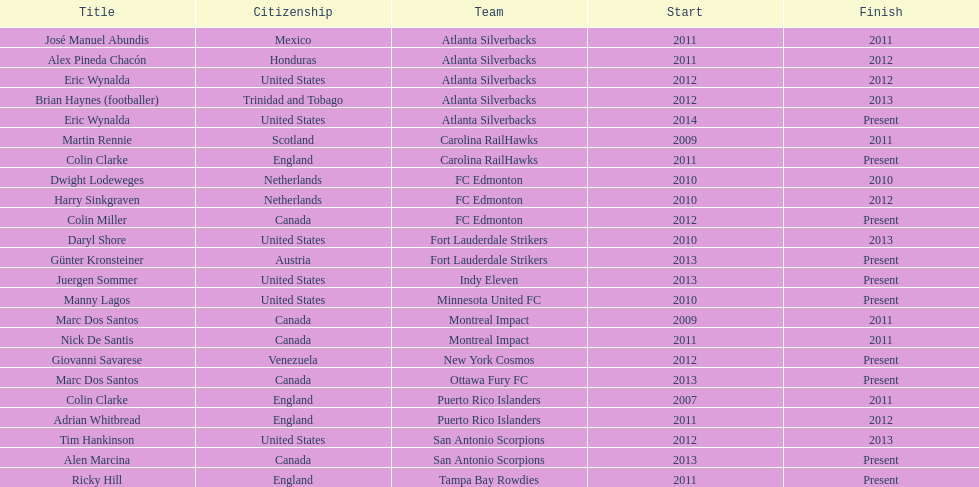What name is listed at the top? José Manuel Abundis. Would you be able to parse every entry in this table? {'header': ['Title', 'Citizenship', 'Team', 'Start', 'Finish'], 'rows': [['José Manuel Abundis', 'Mexico', 'Atlanta Silverbacks', '2011', '2011'], ['Alex Pineda Chacón', 'Honduras', 'Atlanta Silverbacks', '2011', '2012'], ['Eric Wynalda', 'United States', 'Atlanta Silverbacks', '2012', '2012'], ['Brian Haynes (footballer)', 'Trinidad and Tobago', 'Atlanta Silverbacks', '2012', '2013'], ['Eric Wynalda', 'United States', 'Atlanta Silverbacks', '2014', 'Present'], ['Martin Rennie', 'Scotland', 'Carolina RailHawks', '2009', '2011'], ['Colin Clarke', 'England', 'Carolina RailHawks', '2011', 'Present'], ['Dwight Lodeweges', 'Netherlands', 'FC Edmonton', '2010', '2010'], ['Harry Sinkgraven', 'Netherlands', 'FC Edmonton', '2010', '2012'], ['Colin Miller', 'Canada', 'FC Edmonton', '2012', 'Present'], ['Daryl Shore', 'United States', 'Fort Lauderdale Strikers', '2010', '2013'], ['Günter Kronsteiner', 'Austria', 'Fort Lauderdale Strikers', '2013', 'Present'], ['Juergen Sommer', 'United States', 'Indy Eleven', '2013', 'Present'], ['Manny Lagos', 'United States', 'Minnesota United FC', '2010', 'Present'], ['Marc Dos Santos', 'Canada', 'Montreal Impact', '2009', '2011'], ['Nick De Santis', 'Canada', 'Montreal Impact', '2011', '2011'], ['Giovanni Savarese', 'Venezuela', 'New York Cosmos', '2012', 'Present'], ['Marc Dos Santos', 'Canada', 'Ottawa Fury FC', '2013', 'Present'], ['Colin Clarke', 'England', 'Puerto Rico Islanders', '2007', '2011'], ['Adrian Whitbread', 'England', 'Puerto Rico Islanders', '2011', '2012'], ['Tim Hankinson', 'United States', 'San Antonio Scorpions', '2012', '2013'], ['Alen Marcina', 'Canada', 'San Antonio Scorpions', '2013', 'Present'], ['Ricky Hill', 'England', 'Tampa Bay Rowdies', '2011', 'Present']]} 